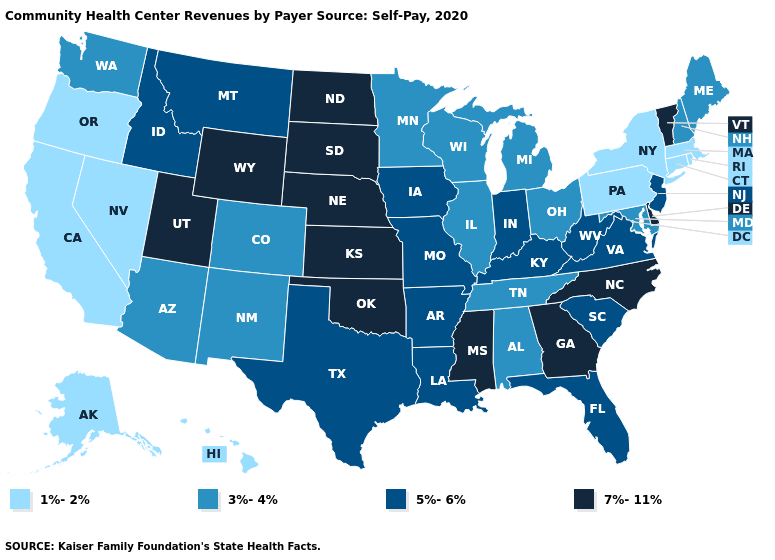What is the highest value in the Northeast ?
Quick response, please. 7%-11%. Which states hav the highest value in the MidWest?
Concise answer only. Kansas, Nebraska, North Dakota, South Dakota. Does Kansas have the highest value in the USA?
Quick response, please. Yes. Name the states that have a value in the range 5%-6%?
Write a very short answer. Arkansas, Florida, Idaho, Indiana, Iowa, Kentucky, Louisiana, Missouri, Montana, New Jersey, South Carolina, Texas, Virginia, West Virginia. Does Idaho have the same value as Virginia?
Concise answer only. Yes. What is the highest value in states that border Texas?
Keep it brief. 7%-11%. What is the value of California?
Be succinct. 1%-2%. Does the first symbol in the legend represent the smallest category?
Answer briefly. Yes. Among the states that border Alabama , does Tennessee have the highest value?
Concise answer only. No. Name the states that have a value in the range 3%-4%?
Write a very short answer. Alabama, Arizona, Colorado, Illinois, Maine, Maryland, Michigan, Minnesota, New Hampshire, New Mexico, Ohio, Tennessee, Washington, Wisconsin. What is the value of Arkansas?
Be succinct. 5%-6%. What is the highest value in states that border Wyoming?
Answer briefly. 7%-11%. What is the value of North Carolina?
Keep it brief. 7%-11%. Among the states that border Virginia , which have the highest value?
Be succinct. North Carolina. Does Alaska have a higher value than Connecticut?
Concise answer only. No. 